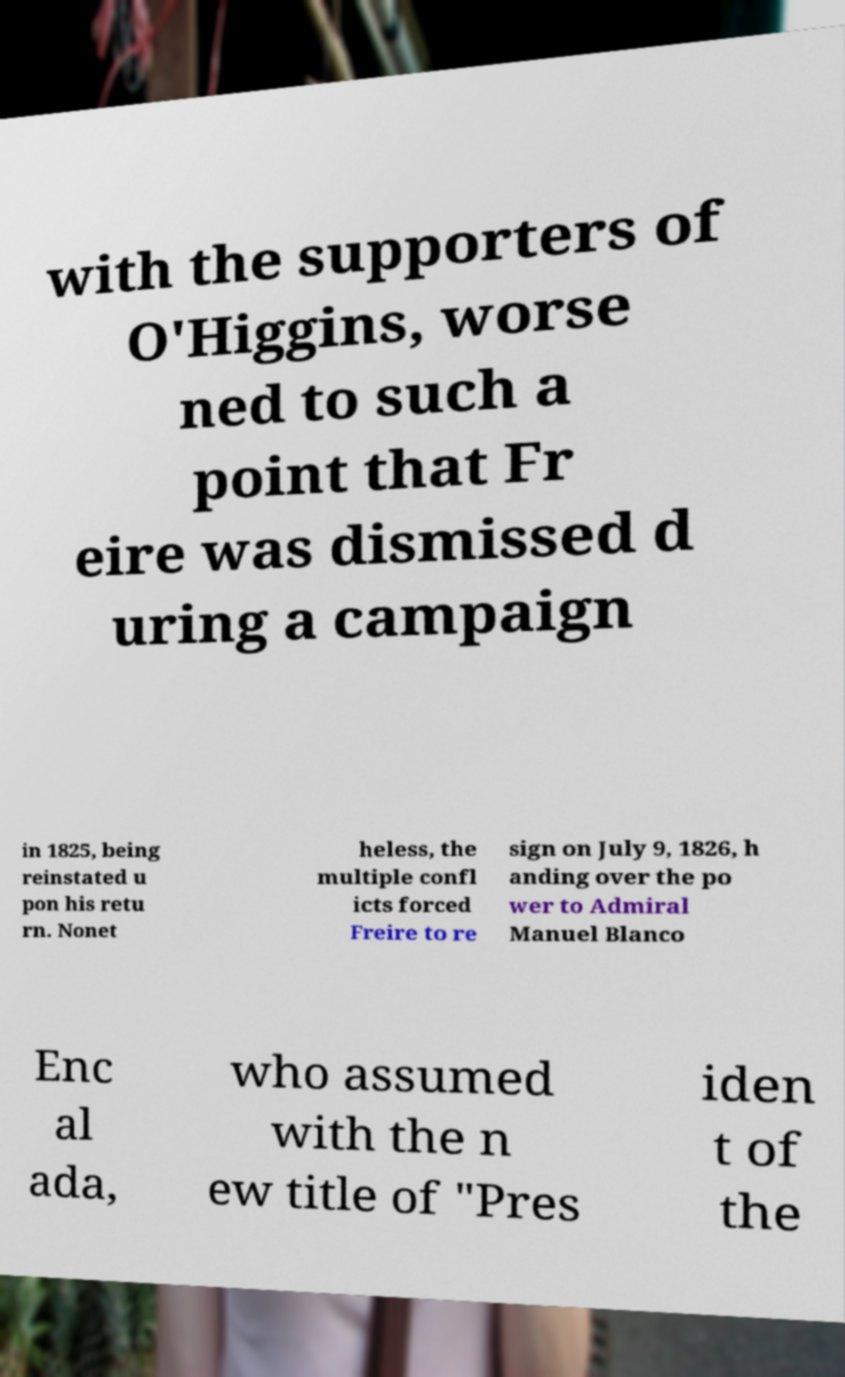What messages or text are displayed in this image? I need them in a readable, typed format. with the supporters of O'Higgins, worse ned to such a point that Fr eire was dismissed d uring a campaign in 1825, being reinstated u pon his retu rn. Nonet heless, the multiple confl icts forced Freire to re sign on July 9, 1826, h anding over the po wer to Admiral Manuel Blanco Enc al ada, who assumed with the n ew title of "Pres iden t of the 